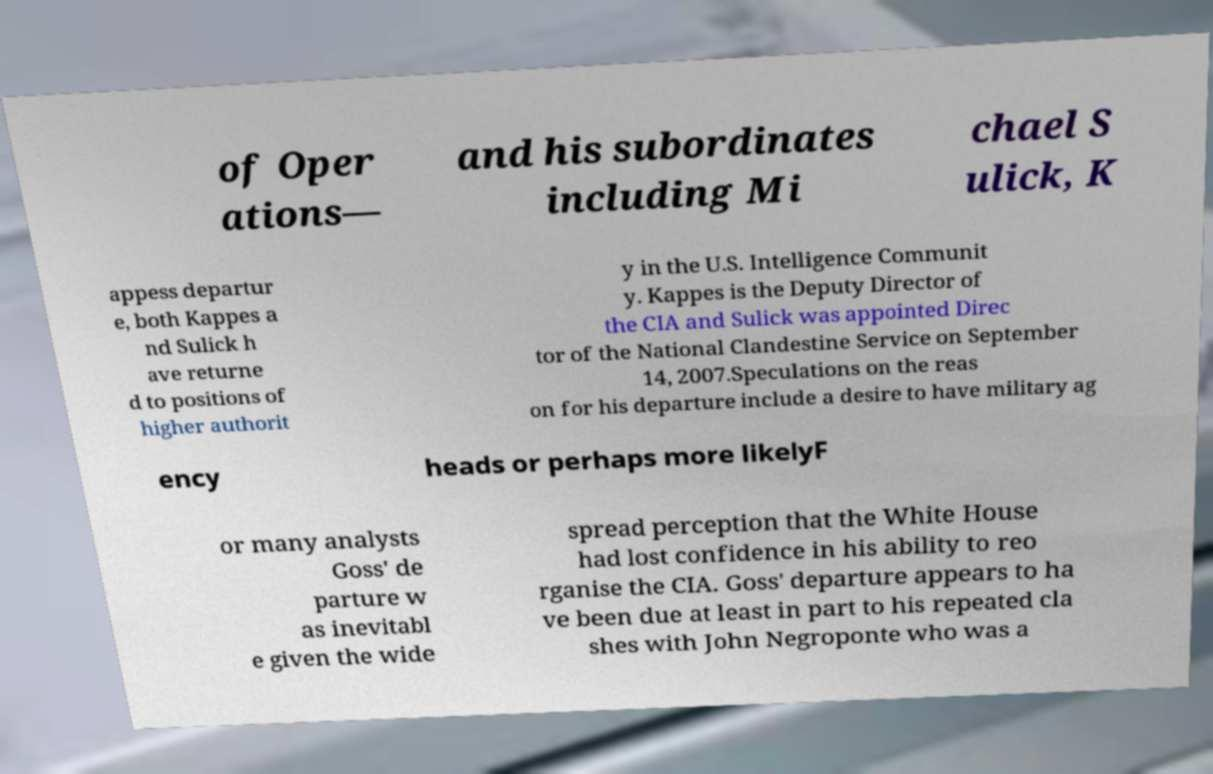What messages or text are displayed in this image? I need them in a readable, typed format. of Oper ations— and his subordinates including Mi chael S ulick, K appess departur e, both Kappes a nd Sulick h ave returne d to positions of higher authorit y in the U.S. Intelligence Communit y. Kappes is the Deputy Director of the CIA and Sulick was appointed Direc tor of the National Clandestine Service on September 14, 2007.Speculations on the reas on for his departure include a desire to have military ag ency heads or perhaps more likelyF or many analysts Goss' de parture w as inevitabl e given the wide spread perception that the White House had lost confidence in his ability to reo rganise the CIA. Goss' departure appears to ha ve been due at least in part to his repeated cla shes with John Negroponte who was a 